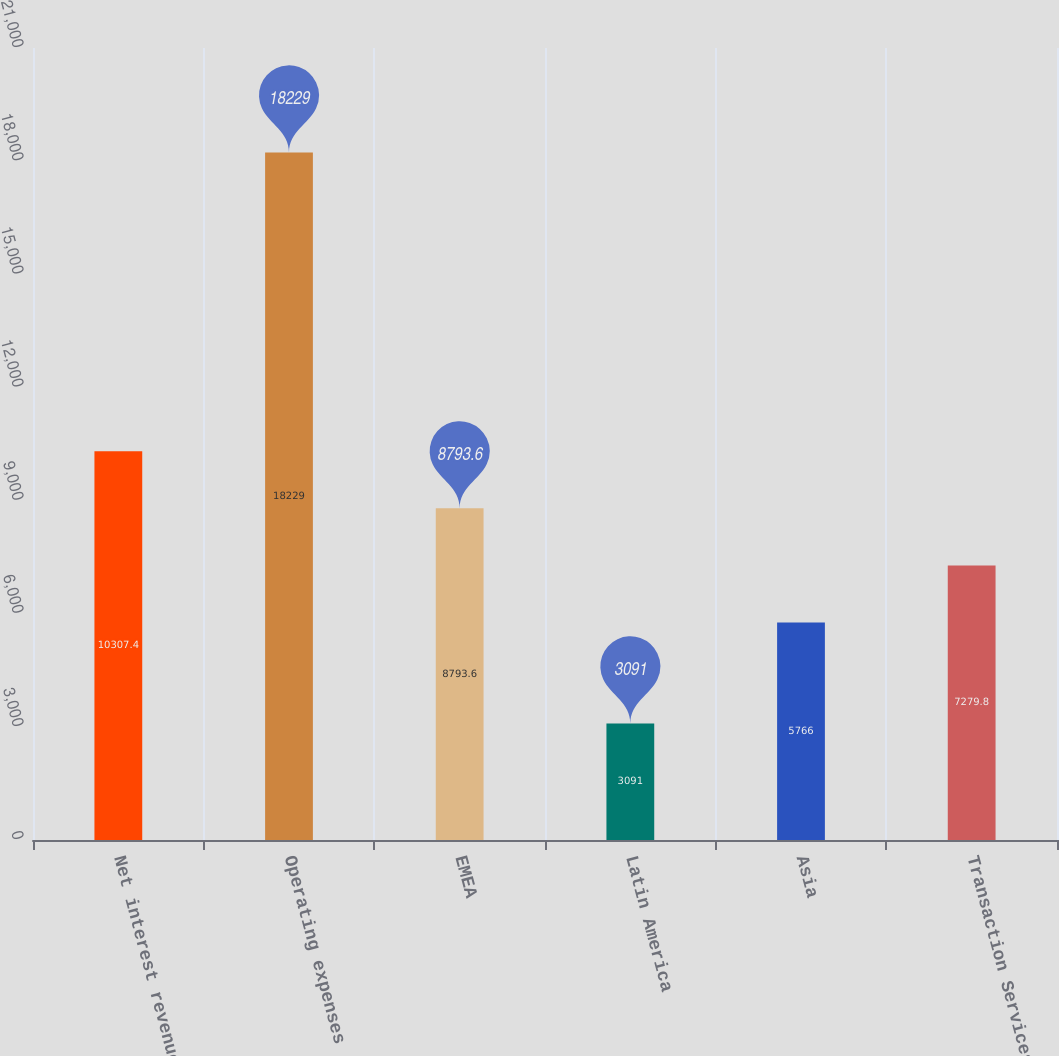<chart> <loc_0><loc_0><loc_500><loc_500><bar_chart><fcel>Net interest revenue<fcel>Operating expenses<fcel>EMEA<fcel>Latin America<fcel>Asia<fcel>Transaction Services<nl><fcel>10307.4<fcel>18229<fcel>8793.6<fcel>3091<fcel>5766<fcel>7279.8<nl></chart> 